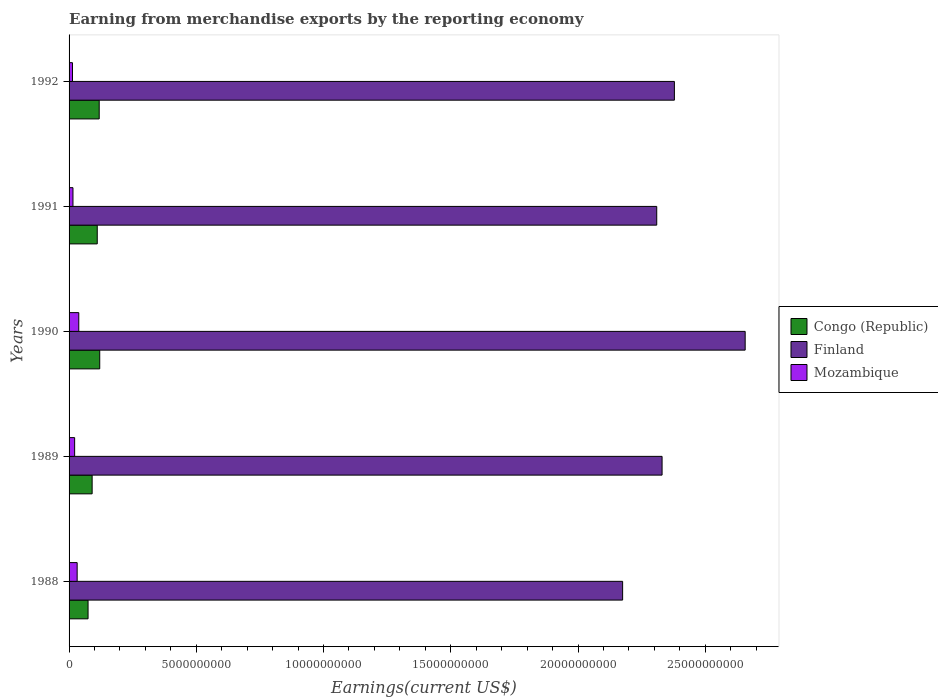How many different coloured bars are there?
Provide a short and direct response. 3. How many groups of bars are there?
Offer a terse response. 5. How many bars are there on the 4th tick from the top?
Your response must be concise. 3. What is the label of the 4th group of bars from the top?
Keep it short and to the point. 1989. In how many cases, is the number of bars for a given year not equal to the number of legend labels?
Provide a succinct answer. 0. What is the amount earned from merchandise exports in Congo (Republic) in 1991?
Offer a terse response. 1.11e+09. Across all years, what is the maximum amount earned from merchandise exports in Mozambique?
Offer a very short reply. 3.81e+08. Across all years, what is the minimum amount earned from merchandise exports in Finland?
Your answer should be very brief. 2.18e+1. In which year was the amount earned from merchandise exports in Mozambique minimum?
Provide a short and direct response. 1992. What is the total amount earned from merchandise exports in Finland in the graph?
Offer a terse response. 1.19e+11. What is the difference between the amount earned from merchandise exports in Finland in 1990 and that in 1992?
Give a very brief answer. 2.78e+09. What is the difference between the amount earned from merchandise exports in Congo (Republic) in 1992 and the amount earned from merchandise exports in Mozambique in 1988?
Keep it short and to the point. 8.67e+08. What is the average amount earned from merchandise exports in Congo (Republic) per year?
Offer a very short reply. 1.03e+09. In the year 1990, what is the difference between the amount earned from merchandise exports in Congo (Republic) and amount earned from merchandise exports in Mozambique?
Your response must be concise. 8.23e+08. What is the ratio of the amount earned from merchandise exports in Finland in 1988 to that in 1991?
Your answer should be compact. 0.94. Is the amount earned from merchandise exports in Finland in 1989 less than that in 1992?
Keep it short and to the point. Yes. What is the difference between the highest and the second highest amount earned from merchandise exports in Congo (Republic)?
Offer a very short reply. 2.05e+07. What is the difference between the highest and the lowest amount earned from merchandise exports in Finland?
Keep it short and to the point. 4.82e+09. In how many years, is the amount earned from merchandise exports in Mozambique greater than the average amount earned from merchandise exports in Mozambique taken over all years?
Provide a succinct answer. 2. Is the sum of the amount earned from merchandise exports in Congo (Republic) in 1990 and 1991 greater than the maximum amount earned from merchandise exports in Finland across all years?
Make the answer very short. No. What does the 2nd bar from the top in 1989 represents?
Give a very brief answer. Finland. What does the 2nd bar from the bottom in 1990 represents?
Ensure brevity in your answer.  Finland. Is it the case that in every year, the sum of the amount earned from merchandise exports in Finland and amount earned from merchandise exports in Mozambique is greater than the amount earned from merchandise exports in Congo (Republic)?
Ensure brevity in your answer.  Yes. How many bars are there?
Offer a very short reply. 15. Are all the bars in the graph horizontal?
Your response must be concise. Yes. How many years are there in the graph?
Give a very brief answer. 5. How are the legend labels stacked?
Ensure brevity in your answer.  Vertical. What is the title of the graph?
Your response must be concise. Earning from merchandise exports by the reporting economy. What is the label or title of the X-axis?
Your answer should be very brief. Earnings(current US$). What is the label or title of the Y-axis?
Ensure brevity in your answer.  Years. What is the Earnings(current US$) of Congo (Republic) in 1988?
Your answer should be very brief. 7.46e+08. What is the Earnings(current US$) in Finland in 1988?
Give a very brief answer. 2.18e+1. What is the Earnings(current US$) of Mozambique in 1988?
Your answer should be compact. 3.18e+08. What is the Earnings(current US$) of Congo (Republic) in 1989?
Offer a terse response. 9.07e+08. What is the Earnings(current US$) in Finland in 1989?
Give a very brief answer. 2.33e+1. What is the Earnings(current US$) in Mozambique in 1989?
Ensure brevity in your answer.  2.19e+08. What is the Earnings(current US$) of Congo (Republic) in 1990?
Provide a succinct answer. 1.20e+09. What is the Earnings(current US$) in Finland in 1990?
Your answer should be compact. 2.66e+1. What is the Earnings(current US$) of Mozambique in 1990?
Keep it short and to the point. 3.81e+08. What is the Earnings(current US$) in Congo (Republic) in 1991?
Provide a short and direct response. 1.11e+09. What is the Earnings(current US$) of Finland in 1991?
Give a very brief answer. 2.31e+1. What is the Earnings(current US$) of Mozambique in 1991?
Keep it short and to the point. 1.53e+08. What is the Earnings(current US$) of Congo (Republic) in 1992?
Your answer should be compact. 1.18e+09. What is the Earnings(current US$) in Finland in 1992?
Give a very brief answer. 2.38e+1. What is the Earnings(current US$) of Mozambique in 1992?
Offer a very short reply. 1.34e+08. Across all years, what is the maximum Earnings(current US$) of Congo (Republic)?
Give a very brief answer. 1.20e+09. Across all years, what is the maximum Earnings(current US$) of Finland?
Give a very brief answer. 2.66e+1. Across all years, what is the maximum Earnings(current US$) in Mozambique?
Provide a short and direct response. 3.81e+08. Across all years, what is the minimum Earnings(current US$) in Congo (Republic)?
Your response must be concise. 7.46e+08. Across all years, what is the minimum Earnings(current US$) in Finland?
Provide a succinct answer. 2.18e+1. Across all years, what is the minimum Earnings(current US$) in Mozambique?
Make the answer very short. 1.34e+08. What is the total Earnings(current US$) in Congo (Republic) in the graph?
Your answer should be very brief. 5.15e+09. What is the total Earnings(current US$) of Finland in the graph?
Offer a very short reply. 1.19e+11. What is the total Earnings(current US$) in Mozambique in the graph?
Give a very brief answer. 1.21e+09. What is the difference between the Earnings(current US$) of Congo (Republic) in 1988 and that in 1989?
Provide a succinct answer. -1.60e+08. What is the difference between the Earnings(current US$) in Finland in 1988 and that in 1989?
Your response must be concise. -1.55e+09. What is the difference between the Earnings(current US$) in Mozambique in 1988 and that in 1989?
Ensure brevity in your answer.  9.85e+07. What is the difference between the Earnings(current US$) in Congo (Republic) in 1988 and that in 1990?
Provide a succinct answer. -4.59e+08. What is the difference between the Earnings(current US$) in Finland in 1988 and that in 1990?
Make the answer very short. -4.82e+09. What is the difference between the Earnings(current US$) in Mozambique in 1988 and that in 1990?
Provide a succinct answer. -6.38e+07. What is the difference between the Earnings(current US$) in Congo (Republic) in 1988 and that in 1991?
Your response must be concise. -3.61e+08. What is the difference between the Earnings(current US$) in Finland in 1988 and that in 1991?
Offer a very short reply. -1.34e+09. What is the difference between the Earnings(current US$) of Mozambique in 1988 and that in 1991?
Your answer should be compact. 1.65e+08. What is the difference between the Earnings(current US$) of Congo (Republic) in 1988 and that in 1992?
Provide a short and direct response. -4.38e+08. What is the difference between the Earnings(current US$) in Finland in 1988 and that in 1992?
Keep it short and to the point. -2.03e+09. What is the difference between the Earnings(current US$) of Mozambique in 1988 and that in 1992?
Keep it short and to the point. 1.83e+08. What is the difference between the Earnings(current US$) in Congo (Republic) in 1989 and that in 1990?
Give a very brief answer. -2.98e+08. What is the difference between the Earnings(current US$) of Finland in 1989 and that in 1990?
Keep it short and to the point. -3.27e+09. What is the difference between the Earnings(current US$) in Mozambique in 1989 and that in 1990?
Your answer should be very brief. -1.62e+08. What is the difference between the Earnings(current US$) in Congo (Republic) in 1989 and that in 1991?
Make the answer very short. -2.01e+08. What is the difference between the Earnings(current US$) in Finland in 1989 and that in 1991?
Offer a terse response. 2.10e+08. What is the difference between the Earnings(current US$) of Mozambique in 1989 and that in 1991?
Keep it short and to the point. 6.60e+07. What is the difference between the Earnings(current US$) of Congo (Republic) in 1989 and that in 1992?
Make the answer very short. -2.78e+08. What is the difference between the Earnings(current US$) of Finland in 1989 and that in 1992?
Ensure brevity in your answer.  -4.84e+08. What is the difference between the Earnings(current US$) in Mozambique in 1989 and that in 1992?
Your answer should be compact. 8.49e+07. What is the difference between the Earnings(current US$) of Congo (Republic) in 1990 and that in 1991?
Ensure brevity in your answer.  9.76e+07. What is the difference between the Earnings(current US$) in Finland in 1990 and that in 1991?
Your response must be concise. 3.48e+09. What is the difference between the Earnings(current US$) in Mozambique in 1990 and that in 1991?
Keep it short and to the point. 2.28e+08. What is the difference between the Earnings(current US$) in Congo (Republic) in 1990 and that in 1992?
Your response must be concise. 2.05e+07. What is the difference between the Earnings(current US$) in Finland in 1990 and that in 1992?
Provide a short and direct response. 2.78e+09. What is the difference between the Earnings(current US$) in Mozambique in 1990 and that in 1992?
Your answer should be very brief. 2.47e+08. What is the difference between the Earnings(current US$) in Congo (Republic) in 1991 and that in 1992?
Keep it short and to the point. -7.72e+07. What is the difference between the Earnings(current US$) in Finland in 1991 and that in 1992?
Make the answer very short. -6.94e+08. What is the difference between the Earnings(current US$) in Mozambique in 1991 and that in 1992?
Keep it short and to the point. 1.89e+07. What is the difference between the Earnings(current US$) in Congo (Republic) in 1988 and the Earnings(current US$) in Finland in 1989?
Offer a terse response. -2.26e+1. What is the difference between the Earnings(current US$) of Congo (Republic) in 1988 and the Earnings(current US$) of Mozambique in 1989?
Provide a succinct answer. 5.27e+08. What is the difference between the Earnings(current US$) in Finland in 1988 and the Earnings(current US$) in Mozambique in 1989?
Offer a terse response. 2.15e+1. What is the difference between the Earnings(current US$) of Congo (Republic) in 1988 and the Earnings(current US$) of Finland in 1990?
Your response must be concise. -2.58e+1. What is the difference between the Earnings(current US$) in Congo (Republic) in 1988 and the Earnings(current US$) in Mozambique in 1990?
Keep it short and to the point. 3.65e+08. What is the difference between the Earnings(current US$) in Finland in 1988 and the Earnings(current US$) in Mozambique in 1990?
Provide a succinct answer. 2.14e+1. What is the difference between the Earnings(current US$) of Congo (Republic) in 1988 and the Earnings(current US$) of Finland in 1991?
Provide a short and direct response. -2.23e+1. What is the difference between the Earnings(current US$) of Congo (Republic) in 1988 and the Earnings(current US$) of Mozambique in 1991?
Your answer should be very brief. 5.93e+08. What is the difference between the Earnings(current US$) in Finland in 1988 and the Earnings(current US$) in Mozambique in 1991?
Your answer should be very brief. 2.16e+1. What is the difference between the Earnings(current US$) in Congo (Republic) in 1988 and the Earnings(current US$) in Finland in 1992?
Give a very brief answer. -2.30e+1. What is the difference between the Earnings(current US$) in Congo (Republic) in 1988 and the Earnings(current US$) in Mozambique in 1992?
Offer a terse response. 6.12e+08. What is the difference between the Earnings(current US$) in Finland in 1988 and the Earnings(current US$) in Mozambique in 1992?
Give a very brief answer. 2.16e+1. What is the difference between the Earnings(current US$) of Congo (Republic) in 1989 and the Earnings(current US$) of Finland in 1990?
Offer a very short reply. -2.57e+1. What is the difference between the Earnings(current US$) in Congo (Republic) in 1989 and the Earnings(current US$) in Mozambique in 1990?
Provide a succinct answer. 5.25e+08. What is the difference between the Earnings(current US$) of Finland in 1989 and the Earnings(current US$) of Mozambique in 1990?
Offer a very short reply. 2.29e+1. What is the difference between the Earnings(current US$) of Congo (Republic) in 1989 and the Earnings(current US$) of Finland in 1991?
Your response must be concise. -2.22e+1. What is the difference between the Earnings(current US$) of Congo (Republic) in 1989 and the Earnings(current US$) of Mozambique in 1991?
Ensure brevity in your answer.  7.53e+08. What is the difference between the Earnings(current US$) of Finland in 1989 and the Earnings(current US$) of Mozambique in 1991?
Make the answer very short. 2.32e+1. What is the difference between the Earnings(current US$) of Congo (Republic) in 1989 and the Earnings(current US$) of Finland in 1992?
Ensure brevity in your answer.  -2.29e+1. What is the difference between the Earnings(current US$) in Congo (Republic) in 1989 and the Earnings(current US$) in Mozambique in 1992?
Provide a succinct answer. 7.72e+08. What is the difference between the Earnings(current US$) in Finland in 1989 and the Earnings(current US$) in Mozambique in 1992?
Your response must be concise. 2.32e+1. What is the difference between the Earnings(current US$) of Congo (Republic) in 1990 and the Earnings(current US$) of Finland in 1991?
Your answer should be compact. -2.19e+1. What is the difference between the Earnings(current US$) of Congo (Republic) in 1990 and the Earnings(current US$) of Mozambique in 1991?
Offer a very short reply. 1.05e+09. What is the difference between the Earnings(current US$) of Finland in 1990 and the Earnings(current US$) of Mozambique in 1991?
Your response must be concise. 2.64e+1. What is the difference between the Earnings(current US$) of Congo (Republic) in 1990 and the Earnings(current US$) of Finland in 1992?
Give a very brief answer. -2.26e+1. What is the difference between the Earnings(current US$) in Congo (Republic) in 1990 and the Earnings(current US$) in Mozambique in 1992?
Offer a terse response. 1.07e+09. What is the difference between the Earnings(current US$) of Finland in 1990 and the Earnings(current US$) of Mozambique in 1992?
Your answer should be very brief. 2.64e+1. What is the difference between the Earnings(current US$) of Congo (Republic) in 1991 and the Earnings(current US$) of Finland in 1992?
Ensure brevity in your answer.  -2.27e+1. What is the difference between the Earnings(current US$) of Congo (Republic) in 1991 and the Earnings(current US$) of Mozambique in 1992?
Your answer should be compact. 9.73e+08. What is the difference between the Earnings(current US$) in Finland in 1991 and the Earnings(current US$) in Mozambique in 1992?
Provide a short and direct response. 2.30e+1. What is the average Earnings(current US$) of Congo (Republic) per year?
Your answer should be compact. 1.03e+09. What is the average Earnings(current US$) of Finland per year?
Offer a very short reply. 2.37e+1. What is the average Earnings(current US$) of Mozambique per year?
Your response must be concise. 2.41e+08. In the year 1988, what is the difference between the Earnings(current US$) in Congo (Republic) and Earnings(current US$) in Finland?
Provide a short and direct response. -2.10e+1. In the year 1988, what is the difference between the Earnings(current US$) in Congo (Republic) and Earnings(current US$) in Mozambique?
Provide a short and direct response. 4.29e+08. In the year 1988, what is the difference between the Earnings(current US$) in Finland and Earnings(current US$) in Mozambique?
Your answer should be compact. 2.14e+1. In the year 1989, what is the difference between the Earnings(current US$) in Congo (Republic) and Earnings(current US$) in Finland?
Your answer should be very brief. -2.24e+1. In the year 1989, what is the difference between the Earnings(current US$) of Congo (Republic) and Earnings(current US$) of Mozambique?
Provide a succinct answer. 6.87e+08. In the year 1989, what is the difference between the Earnings(current US$) of Finland and Earnings(current US$) of Mozambique?
Give a very brief answer. 2.31e+1. In the year 1990, what is the difference between the Earnings(current US$) of Congo (Republic) and Earnings(current US$) of Finland?
Offer a very short reply. -2.54e+1. In the year 1990, what is the difference between the Earnings(current US$) in Congo (Republic) and Earnings(current US$) in Mozambique?
Ensure brevity in your answer.  8.23e+08. In the year 1990, what is the difference between the Earnings(current US$) of Finland and Earnings(current US$) of Mozambique?
Keep it short and to the point. 2.62e+1. In the year 1991, what is the difference between the Earnings(current US$) of Congo (Republic) and Earnings(current US$) of Finland?
Give a very brief answer. -2.20e+1. In the year 1991, what is the difference between the Earnings(current US$) of Congo (Republic) and Earnings(current US$) of Mozambique?
Give a very brief answer. 9.54e+08. In the year 1991, what is the difference between the Earnings(current US$) in Finland and Earnings(current US$) in Mozambique?
Provide a succinct answer. 2.29e+1. In the year 1992, what is the difference between the Earnings(current US$) in Congo (Republic) and Earnings(current US$) in Finland?
Give a very brief answer. -2.26e+1. In the year 1992, what is the difference between the Earnings(current US$) of Congo (Republic) and Earnings(current US$) of Mozambique?
Ensure brevity in your answer.  1.05e+09. In the year 1992, what is the difference between the Earnings(current US$) of Finland and Earnings(current US$) of Mozambique?
Give a very brief answer. 2.37e+1. What is the ratio of the Earnings(current US$) of Congo (Republic) in 1988 to that in 1989?
Your response must be concise. 0.82. What is the ratio of the Earnings(current US$) of Finland in 1988 to that in 1989?
Your response must be concise. 0.93. What is the ratio of the Earnings(current US$) in Mozambique in 1988 to that in 1989?
Make the answer very short. 1.45. What is the ratio of the Earnings(current US$) in Congo (Republic) in 1988 to that in 1990?
Make the answer very short. 0.62. What is the ratio of the Earnings(current US$) in Finland in 1988 to that in 1990?
Give a very brief answer. 0.82. What is the ratio of the Earnings(current US$) of Mozambique in 1988 to that in 1990?
Ensure brevity in your answer.  0.83. What is the ratio of the Earnings(current US$) of Congo (Republic) in 1988 to that in 1991?
Your answer should be very brief. 0.67. What is the ratio of the Earnings(current US$) of Finland in 1988 to that in 1991?
Ensure brevity in your answer.  0.94. What is the ratio of the Earnings(current US$) in Mozambique in 1988 to that in 1991?
Ensure brevity in your answer.  2.07. What is the ratio of the Earnings(current US$) in Congo (Republic) in 1988 to that in 1992?
Provide a short and direct response. 0.63. What is the ratio of the Earnings(current US$) in Finland in 1988 to that in 1992?
Your answer should be very brief. 0.91. What is the ratio of the Earnings(current US$) of Mozambique in 1988 to that in 1992?
Your response must be concise. 2.37. What is the ratio of the Earnings(current US$) in Congo (Republic) in 1989 to that in 1990?
Offer a terse response. 0.75. What is the ratio of the Earnings(current US$) in Finland in 1989 to that in 1990?
Provide a short and direct response. 0.88. What is the ratio of the Earnings(current US$) in Mozambique in 1989 to that in 1990?
Offer a terse response. 0.57. What is the ratio of the Earnings(current US$) of Congo (Republic) in 1989 to that in 1991?
Keep it short and to the point. 0.82. What is the ratio of the Earnings(current US$) of Finland in 1989 to that in 1991?
Provide a succinct answer. 1.01. What is the ratio of the Earnings(current US$) of Mozambique in 1989 to that in 1991?
Your answer should be very brief. 1.43. What is the ratio of the Earnings(current US$) of Congo (Republic) in 1989 to that in 1992?
Provide a succinct answer. 0.77. What is the ratio of the Earnings(current US$) of Finland in 1989 to that in 1992?
Provide a short and direct response. 0.98. What is the ratio of the Earnings(current US$) in Mozambique in 1989 to that in 1992?
Offer a very short reply. 1.63. What is the ratio of the Earnings(current US$) of Congo (Republic) in 1990 to that in 1991?
Your answer should be compact. 1.09. What is the ratio of the Earnings(current US$) in Finland in 1990 to that in 1991?
Ensure brevity in your answer.  1.15. What is the ratio of the Earnings(current US$) of Mozambique in 1990 to that in 1991?
Give a very brief answer. 2.49. What is the ratio of the Earnings(current US$) in Congo (Republic) in 1990 to that in 1992?
Make the answer very short. 1.02. What is the ratio of the Earnings(current US$) in Finland in 1990 to that in 1992?
Give a very brief answer. 1.12. What is the ratio of the Earnings(current US$) of Mozambique in 1990 to that in 1992?
Your answer should be compact. 2.84. What is the ratio of the Earnings(current US$) of Congo (Republic) in 1991 to that in 1992?
Your response must be concise. 0.93. What is the ratio of the Earnings(current US$) in Finland in 1991 to that in 1992?
Provide a short and direct response. 0.97. What is the ratio of the Earnings(current US$) in Mozambique in 1991 to that in 1992?
Your answer should be very brief. 1.14. What is the difference between the highest and the second highest Earnings(current US$) in Congo (Republic)?
Give a very brief answer. 2.05e+07. What is the difference between the highest and the second highest Earnings(current US$) of Finland?
Ensure brevity in your answer.  2.78e+09. What is the difference between the highest and the second highest Earnings(current US$) in Mozambique?
Provide a succinct answer. 6.38e+07. What is the difference between the highest and the lowest Earnings(current US$) of Congo (Republic)?
Provide a succinct answer. 4.59e+08. What is the difference between the highest and the lowest Earnings(current US$) of Finland?
Your answer should be very brief. 4.82e+09. What is the difference between the highest and the lowest Earnings(current US$) in Mozambique?
Make the answer very short. 2.47e+08. 